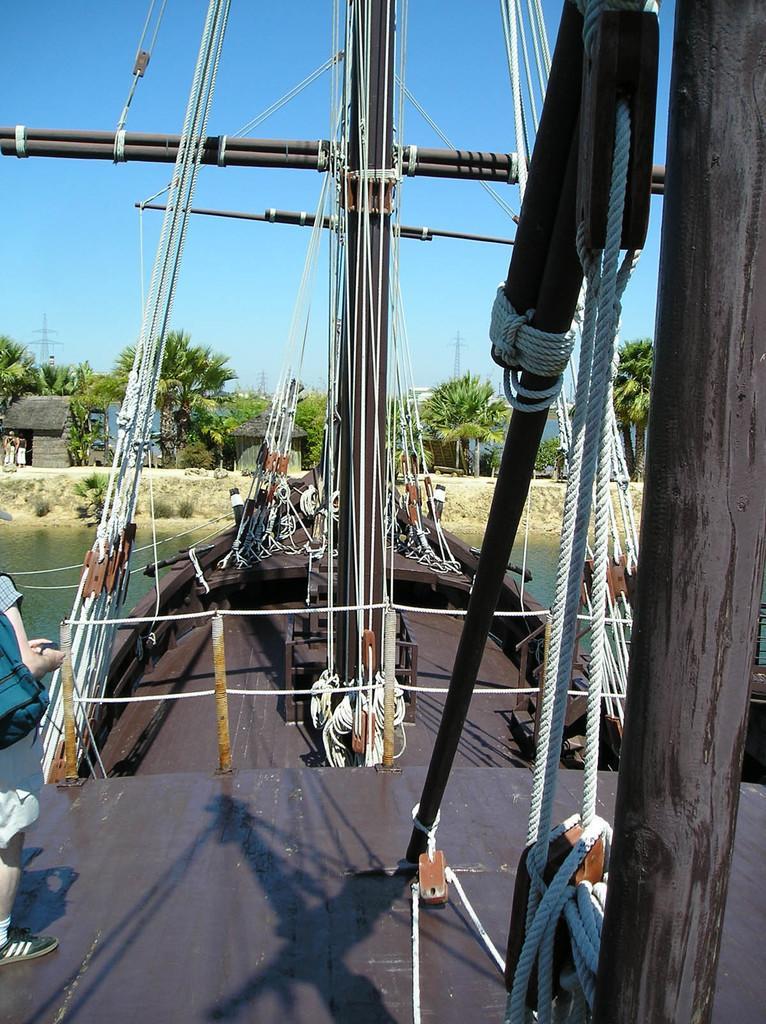Can you describe this image briefly? In front of the image there is a person standing on the ship with ropes, metal rods and wooden poles on the water, in front of the ship there are trees, houses and electric poles. 